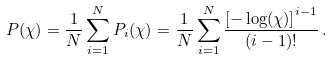Convert formula to latex. <formula><loc_0><loc_0><loc_500><loc_500>P ( \chi ) = \frac { 1 } { N } \sum _ { i = 1 } ^ { N } P _ { i } ( \chi ) = \frac { 1 } { N } \sum _ { i = 1 } ^ { N } \frac { \left [ - \log ( \chi ) \right ] ^ { i - 1 } } { ( i - 1 ) ! } \, .</formula> 